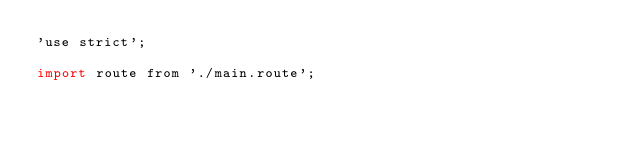<code> <loc_0><loc_0><loc_500><loc_500><_JavaScript_>'use strict';

import route from './main.route';
</code> 